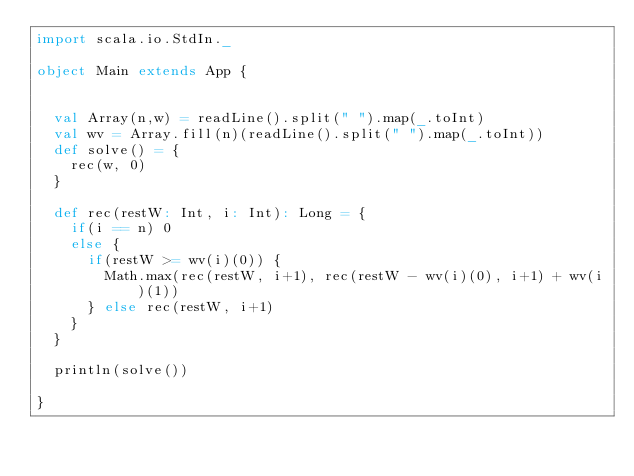<code> <loc_0><loc_0><loc_500><loc_500><_Scala_>import scala.io.StdIn._

object Main extends App {


  val Array(n,w) = readLine().split(" ").map(_.toInt)
  val wv = Array.fill(n)(readLine().split(" ").map(_.toInt))
  def solve() = {
    rec(w, 0)
  }

  def rec(restW: Int, i: Int): Long = {
    if(i == n) 0
    else {
      if(restW >= wv(i)(0)) {
        Math.max(rec(restW, i+1), rec(restW - wv(i)(0), i+1) + wv(i)(1))
      } else rec(restW, i+1)
    }
  }

  println(solve())

}

</code> 